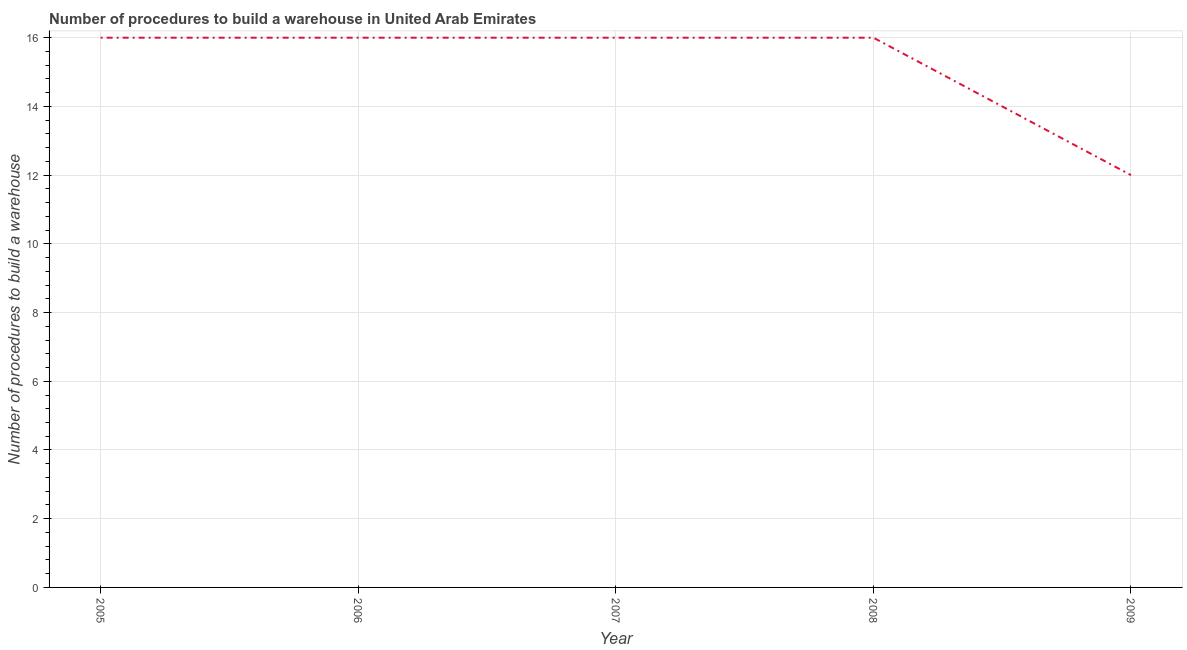What is the number of procedures to build a warehouse in 2008?
Offer a terse response. 16. Across all years, what is the maximum number of procedures to build a warehouse?
Provide a succinct answer. 16. Across all years, what is the minimum number of procedures to build a warehouse?
Give a very brief answer. 12. In which year was the number of procedures to build a warehouse maximum?
Offer a very short reply. 2005. In which year was the number of procedures to build a warehouse minimum?
Ensure brevity in your answer.  2009. What is the sum of the number of procedures to build a warehouse?
Your answer should be compact. 76. What is the average number of procedures to build a warehouse per year?
Make the answer very short. 15.2. In how many years, is the number of procedures to build a warehouse greater than 10.8 ?
Give a very brief answer. 5. Do a majority of the years between 2009 and 2008 (inclusive) have number of procedures to build a warehouse greater than 6.4 ?
Ensure brevity in your answer.  No. Is the number of procedures to build a warehouse in 2005 less than that in 2009?
Provide a short and direct response. No. Is the difference between the number of procedures to build a warehouse in 2005 and 2006 greater than the difference between any two years?
Your response must be concise. No. What is the difference between the highest and the lowest number of procedures to build a warehouse?
Keep it short and to the point. 4. In how many years, is the number of procedures to build a warehouse greater than the average number of procedures to build a warehouse taken over all years?
Keep it short and to the point. 4. Does the number of procedures to build a warehouse monotonically increase over the years?
Ensure brevity in your answer.  No. How many years are there in the graph?
Your answer should be compact. 5. What is the difference between two consecutive major ticks on the Y-axis?
Your answer should be very brief. 2. What is the title of the graph?
Keep it short and to the point. Number of procedures to build a warehouse in United Arab Emirates. What is the label or title of the X-axis?
Give a very brief answer. Year. What is the label or title of the Y-axis?
Your response must be concise. Number of procedures to build a warehouse. What is the Number of procedures to build a warehouse of 2005?
Provide a short and direct response. 16. What is the difference between the Number of procedures to build a warehouse in 2005 and 2006?
Offer a very short reply. 0. What is the difference between the Number of procedures to build a warehouse in 2005 and 2008?
Your answer should be very brief. 0. What is the difference between the Number of procedures to build a warehouse in 2005 and 2009?
Your answer should be compact. 4. What is the difference between the Number of procedures to build a warehouse in 2006 and 2008?
Give a very brief answer. 0. What is the difference between the Number of procedures to build a warehouse in 2006 and 2009?
Keep it short and to the point. 4. What is the difference between the Number of procedures to build a warehouse in 2007 and 2009?
Provide a short and direct response. 4. What is the ratio of the Number of procedures to build a warehouse in 2005 to that in 2006?
Offer a terse response. 1. What is the ratio of the Number of procedures to build a warehouse in 2005 to that in 2007?
Provide a short and direct response. 1. What is the ratio of the Number of procedures to build a warehouse in 2005 to that in 2009?
Keep it short and to the point. 1.33. What is the ratio of the Number of procedures to build a warehouse in 2006 to that in 2007?
Provide a succinct answer. 1. What is the ratio of the Number of procedures to build a warehouse in 2006 to that in 2009?
Keep it short and to the point. 1.33. What is the ratio of the Number of procedures to build a warehouse in 2007 to that in 2008?
Offer a terse response. 1. What is the ratio of the Number of procedures to build a warehouse in 2007 to that in 2009?
Make the answer very short. 1.33. What is the ratio of the Number of procedures to build a warehouse in 2008 to that in 2009?
Offer a terse response. 1.33. 